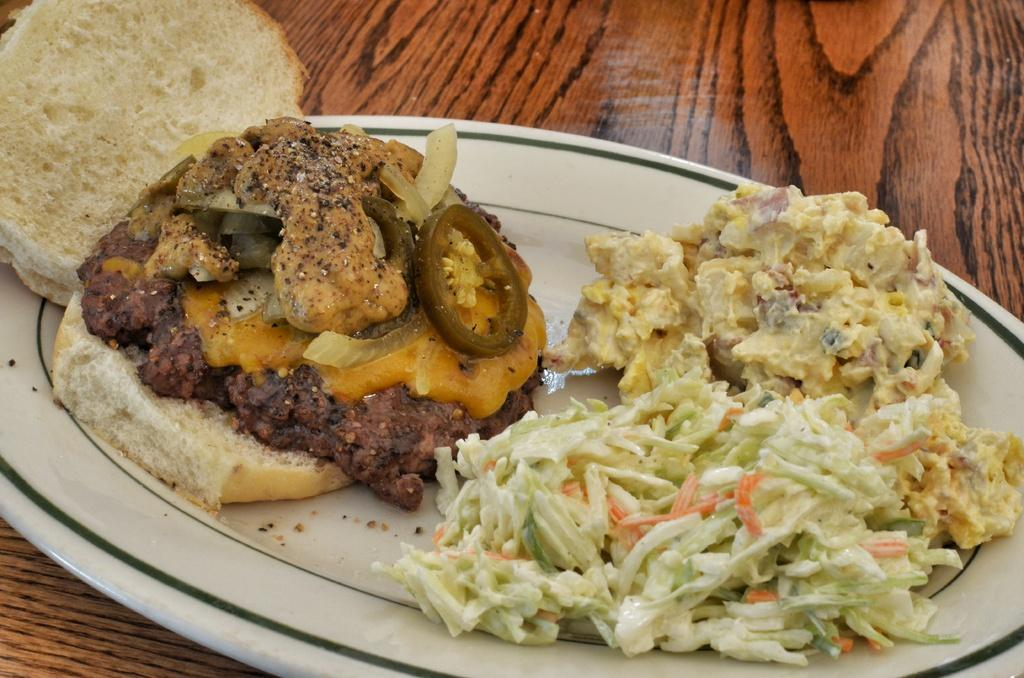What is on the table in the image? There is a white plate on the table. What is on the plate? The plate contains meat, cucumber pieces, onion pieces, and cabbage. Are there any other food items on the plate? Yes, there are other food items on the plate. How is the rice being transported in the image? There is no rice present in the image. What type of waste is visible in the image? There is no waste visible in the image. 